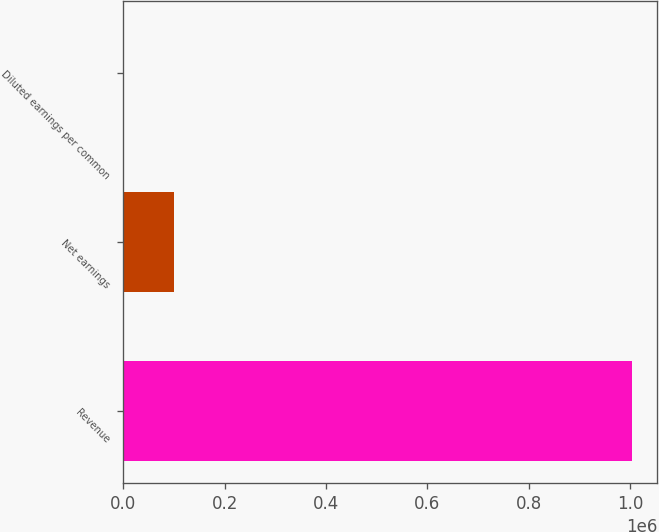Convert chart to OTSL. <chart><loc_0><loc_0><loc_500><loc_500><bar_chart><fcel>Revenue<fcel>Net earnings<fcel>Diluted earnings per common<nl><fcel>1.00311e+06<fcel>100312<fcel>1.21<nl></chart> 